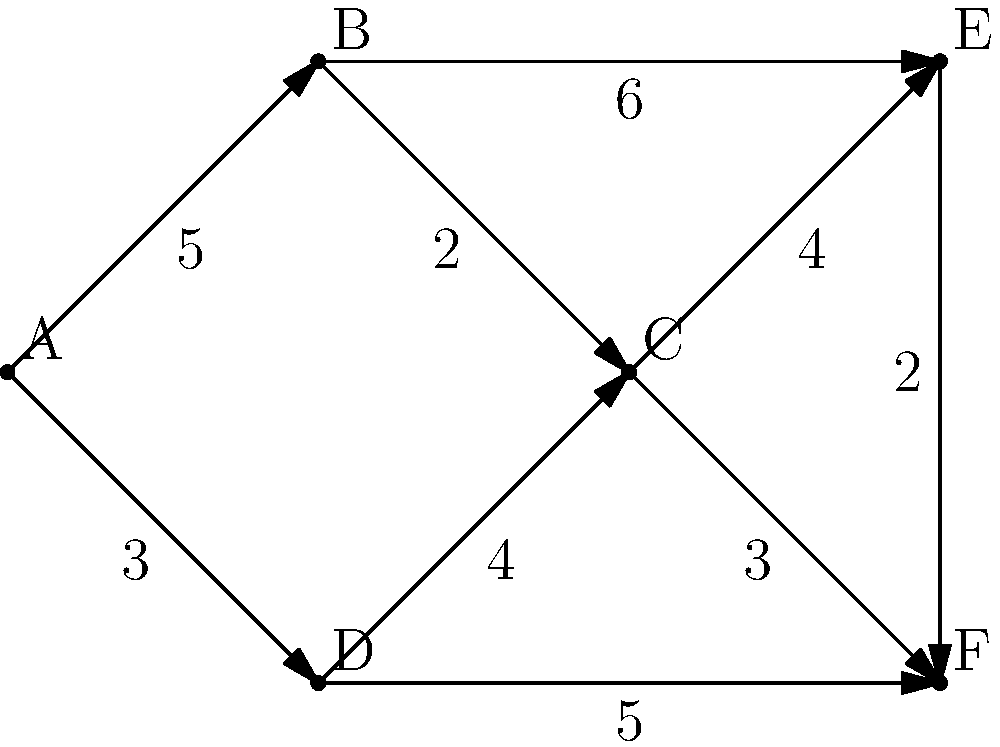As a network security manager, you're tasked with optimizing the data flow in your corporation's network. The network is represented by the weighted directed graph above, where vertices represent network nodes and edge weights represent data transfer costs. What is the minimum cost path from node A to node F, and what is its total cost? To find the minimum cost path from node A to node F, we'll use Dijkstra's algorithm:

1. Initialize:
   - Set A's distance to 0, all others to infinity.
   - Set all nodes as unvisited.
   - Set A as the current node.

2. For the current node, consider all unvisited neighbors and calculate their tentative distances:
   - A to B: 0 + 5 = 5
   - A to D: 0 + 3 = 3
   Update D's distance to 3, it's smaller than infinity.

3. Mark A as visited. Set D as the current node (smallest tentative distance).

4. From D:
   - D to C: 3 + 4 = 7
   - D to F: 3 + 5 = 8
   Update both C and F's distances.

5. Mark D as visited. Set C as the current node.

6. From C:
   - C to E: 7 + 4 = 11
   - C to F: 7 + 3 = 10
   Update F's distance to 10.

7. Mark C as visited. Set F as the current node (smallest tentative distance among unvisited).

8. F has no unvisited neighbors. Algorithm ends.

The minimum cost path is A → D → C → F, with a total cost of 10.
Answer: Path: A → D → C → F, Cost: 10 